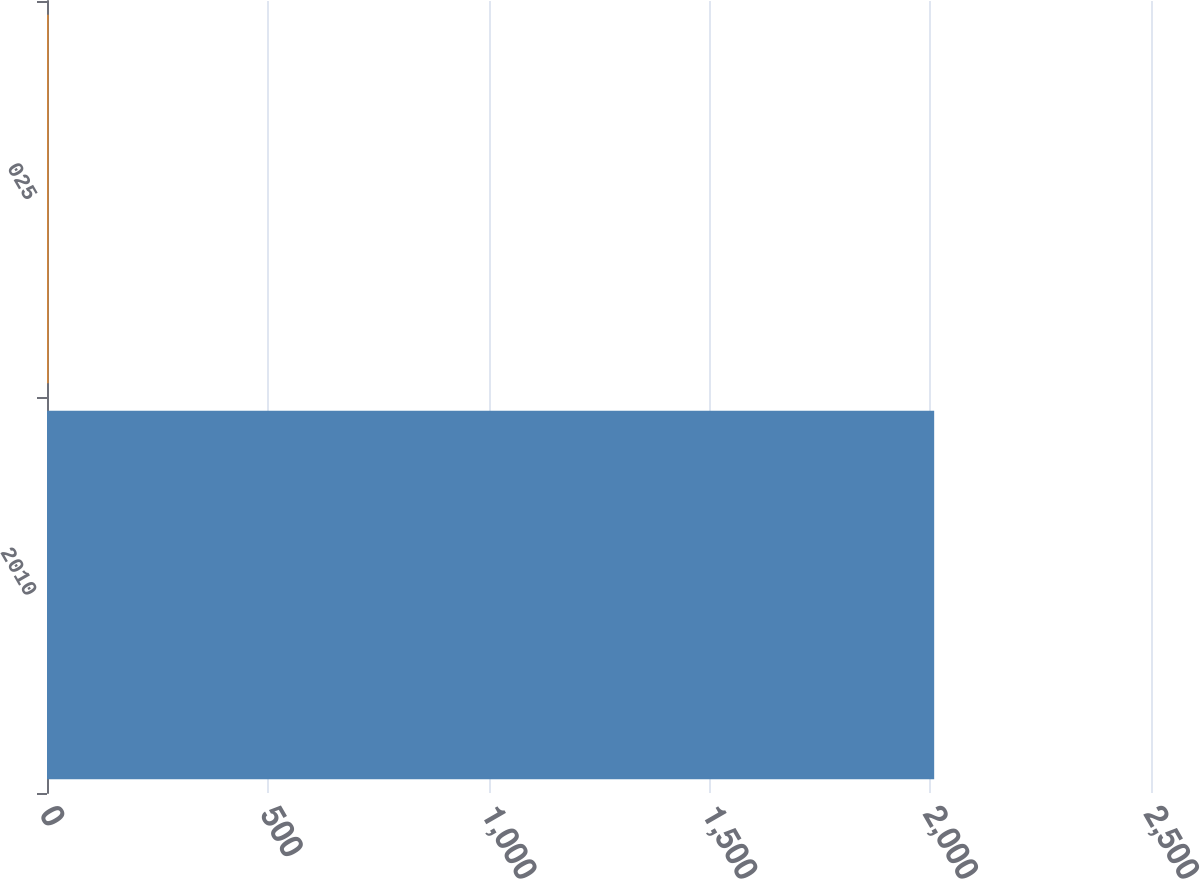Convert chart. <chart><loc_0><loc_0><loc_500><loc_500><bar_chart><fcel>2010<fcel>025<nl><fcel>2009<fcel>3.97<nl></chart> 